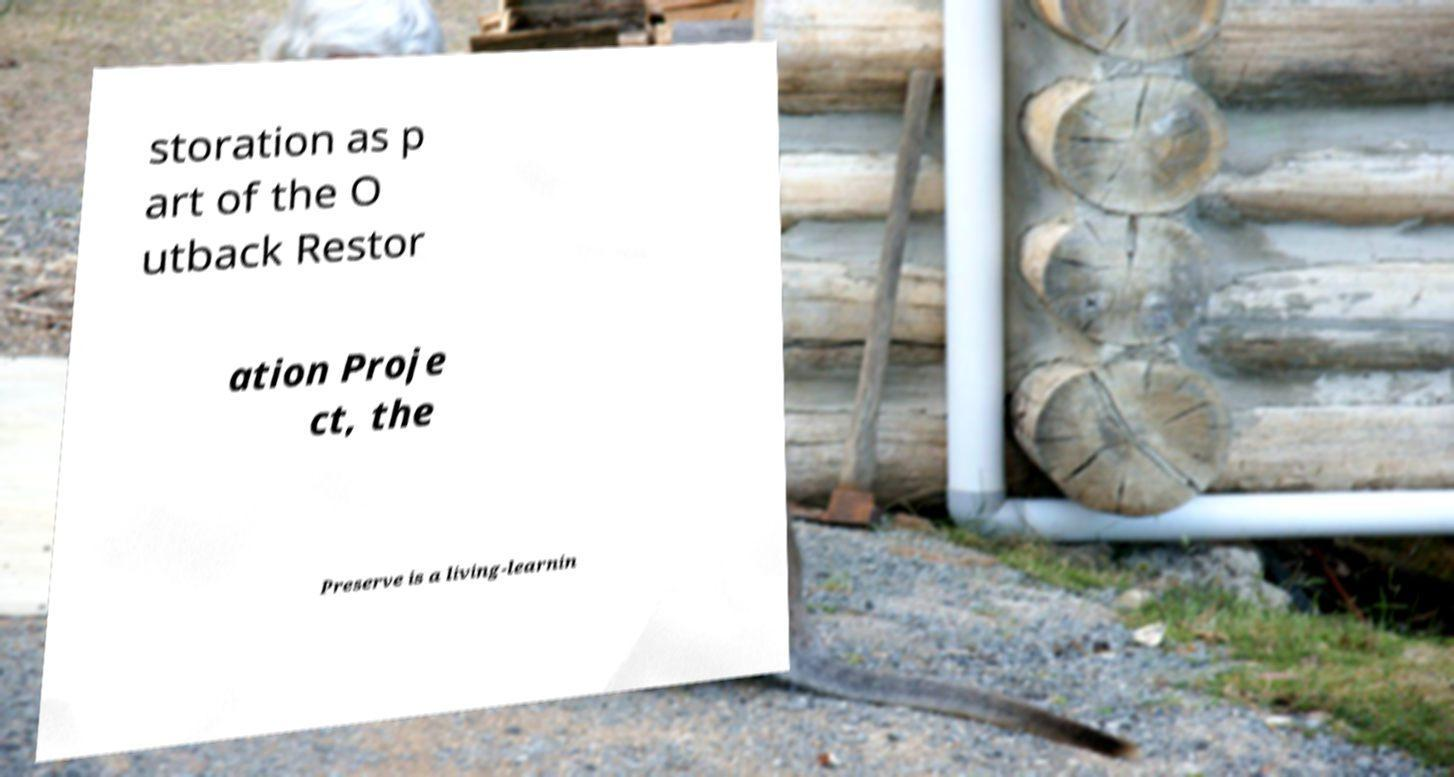Can you accurately transcribe the text from the provided image for me? storation as p art of the O utback Restor ation Proje ct, the Preserve is a living-learnin 